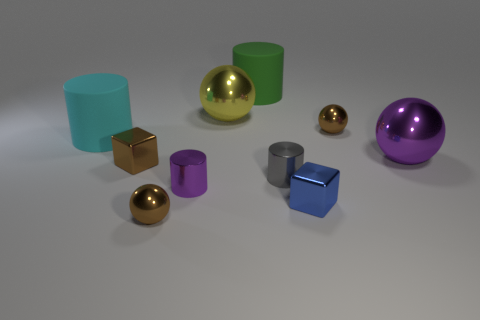Subtract all cylinders. How many objects are left? 6 Add 9 big cyan rubber things. How many big cyan rubber things exist? 10 Subtract 0 cyan spheres. How many objects are left? 10 Subtract all big cyan shiny things. Subtract all blue metallic blocks. How many objects are left? 9 Add 2 purple shiny things. How many purple shiny things are left? 4 